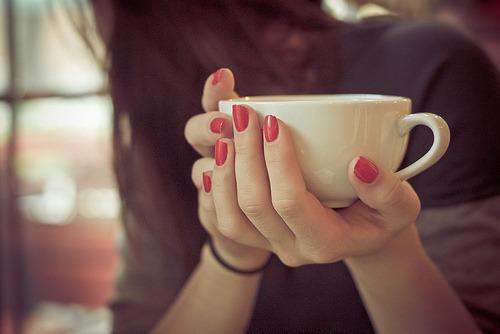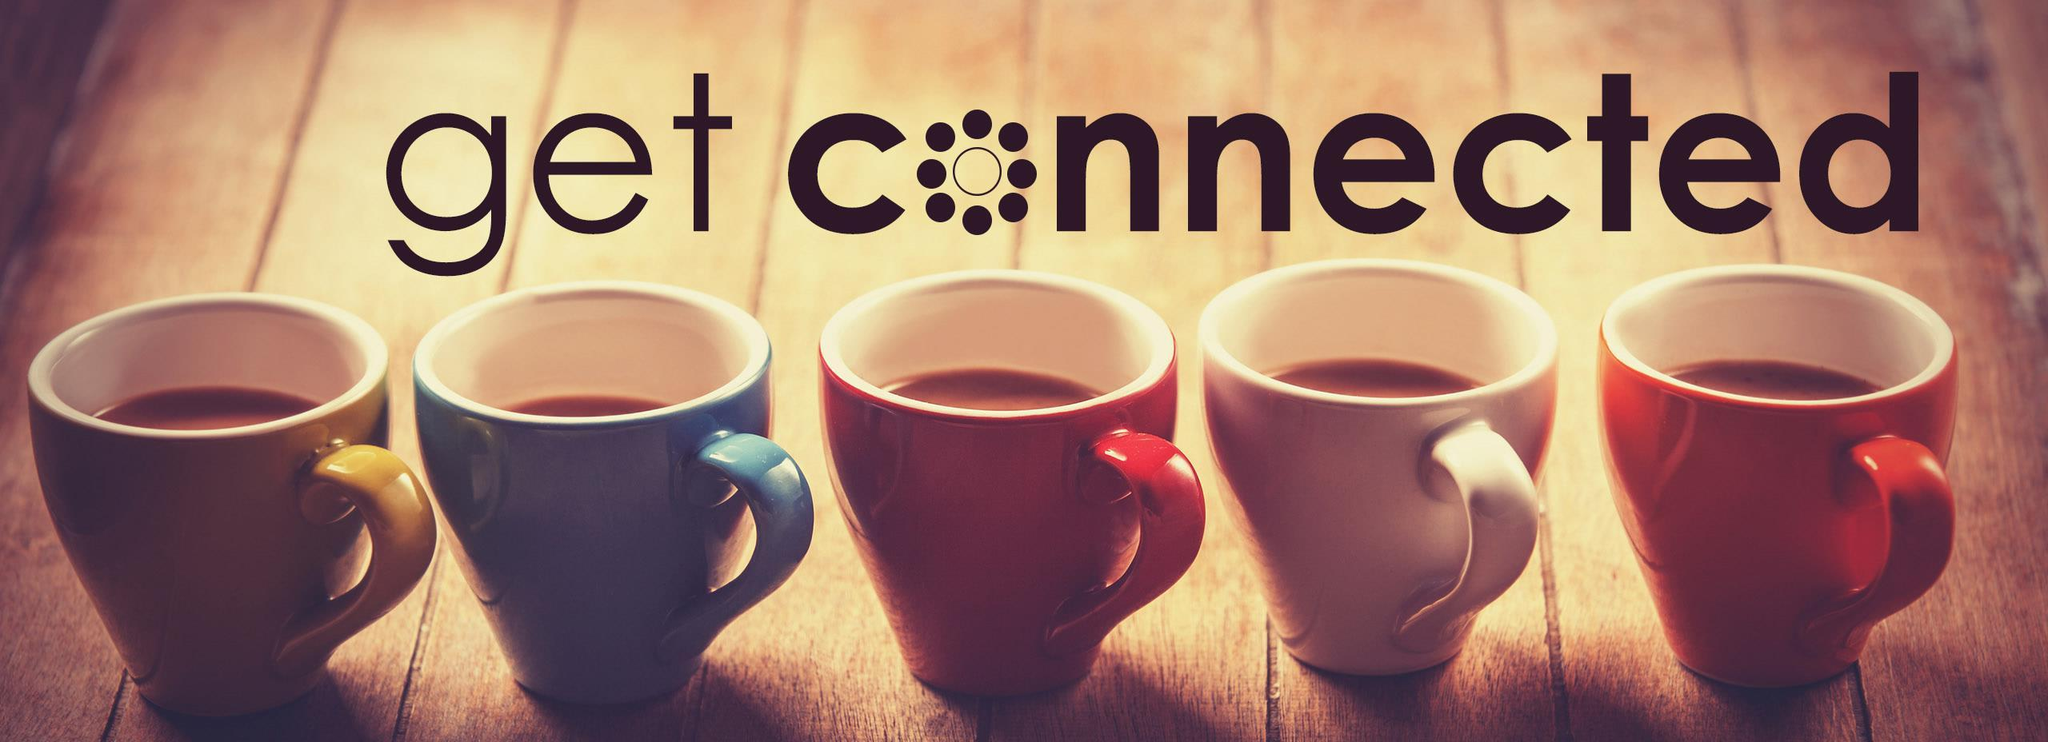The first image is the image on the left, the second image is the image on the right. For the images displayed, is the sentence "Some cups are made of plastic." factually correct? Answer yes or no. No. 